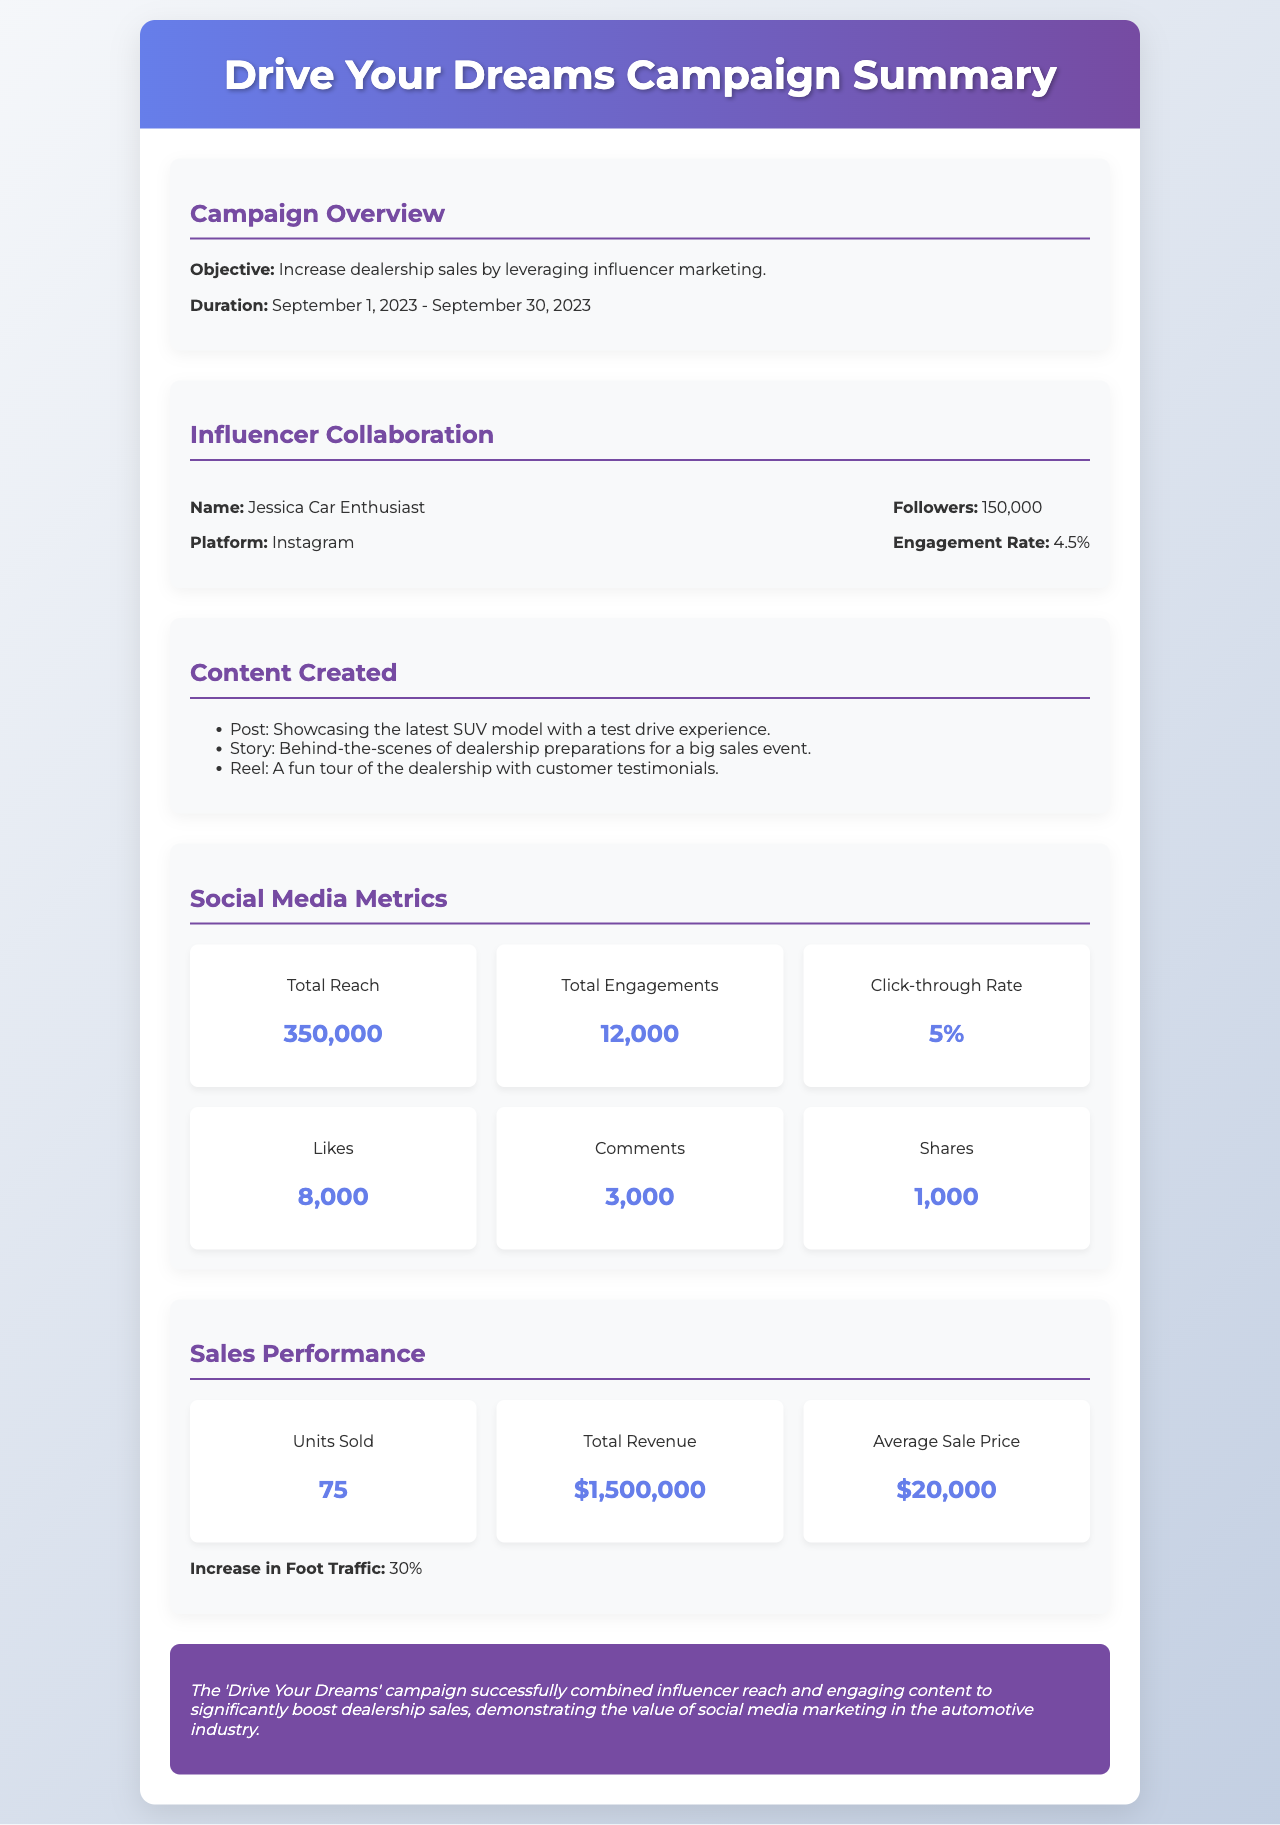what is the campaign objective? The objective of the campaign is to increase dealership sales by leveraging influencer marketing.
Answer: increase dealership sales by leveraging influencer marketing who is the influencer collaborating on this campaign? The influencer collaborating on this campaign is Jessica Car Enthusiast.
Answer: Jessica Car Enthusiast what is the influencer's engagement rate? The engagement rate of the influencer is given in the document as 4.5%.
Answer: 4.5% how many total engagements were recorded? Total engagements are explicitly mentioned in the metrics section as 12,000.
Answer: 12,000 what was the total reach of the campaign? The total reach is stated in the document as 350,000.
Answer: 350,000 what is the increase in foot traffic due to the campaign? The document indicates an increase in foot traffic of 30%.
Answer: 30% how many units were sold during the campaign? The number of units sold is mentioned in the sales performance section as 75.
Answer: 75 what was the average sale price? The average sale price is specified in the document as $20,000.
Answer: $20,000 what content type showcased the latest SUV model? The type of content that showcased the latest SUV model is a post.
Answer: post 